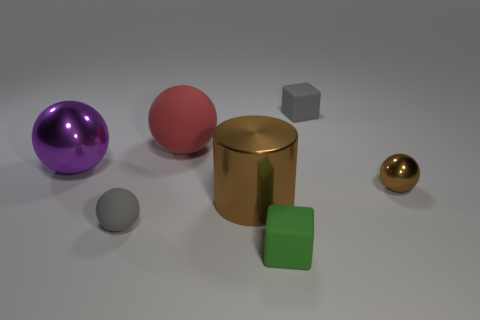Is there any other thing that has the same shape as the large brown thing?
Provide a short and direct response. No. Are there fewer green things left of the brown metal cylinder than small green matte blocks?
Your answer should be compact. Yes. What shape is the large metal object right of the small ball to the left of the gray thing behind the brown metallic cylinder?
Ensure brevity in your answer.  Cylinder. Is the color of the tiny rubber sphere the same as the cylinder?
Provide a short and direct response. No. Are there more blocks than large matte spheres?
Your answer should be compact. Yes. How many other objects are there of the same material as the cylinder?
Your response must be concise. 2. How many things are large purple metal things or cubes behind the small metallic thing?
Keep it short and to the point. 2. Are there fewer small gray matte cubes than tiny gray objects?
Make the answer very short. Yes. What is the color of the big metallic thing that is to the left of the small gray rubber object in front of the gray rubber object that is on the right side of the small rubber sphere?
Provide a short and direct response. Purple. Are the small brown thing and the large cylinder made of the same material?
Ensure brevity in your answer.  Yes. 